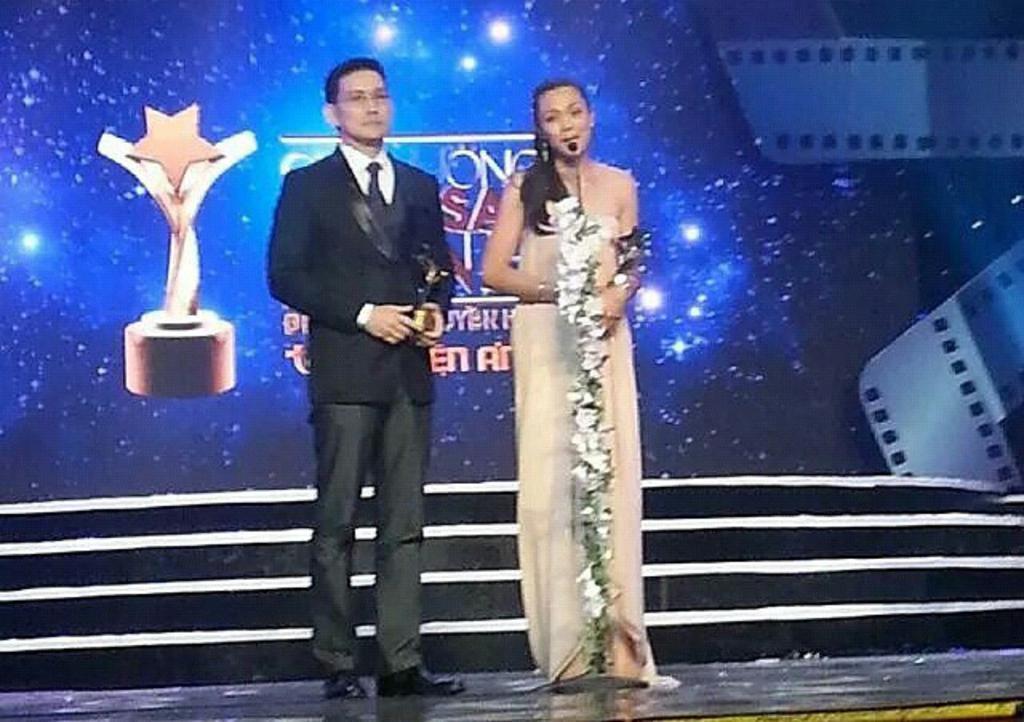How would you summarize this image in a sentence or two? In this image I can see a person wearing black colored dress and a woman wearing cream colored dress are standing. I can see the microphone and few flowers around it. In the background I can see few stairs and a huge screen. 